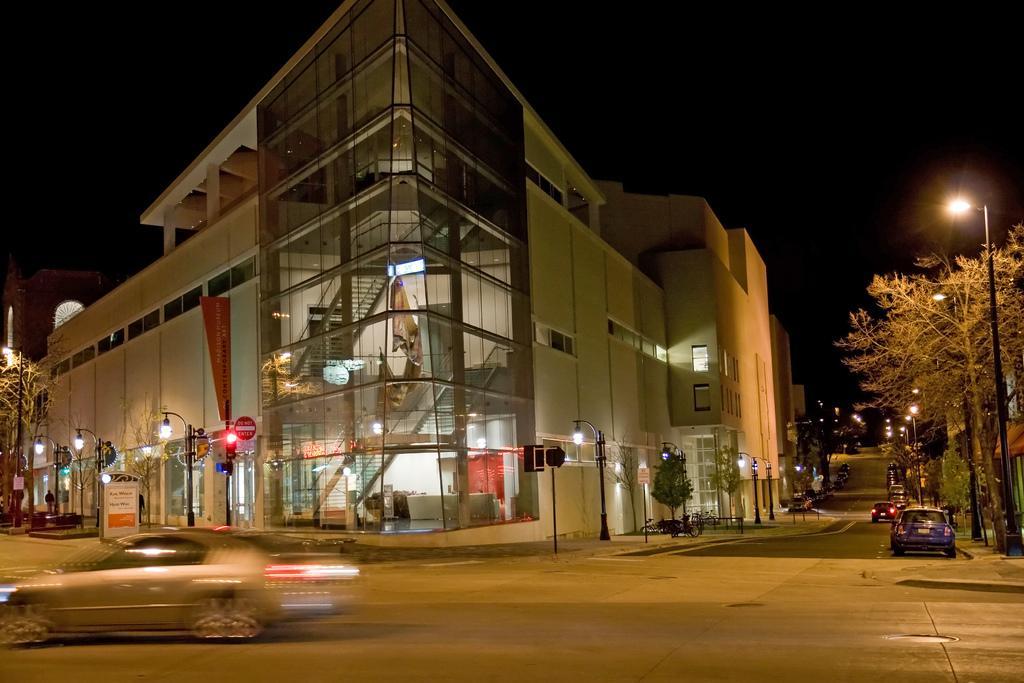Can you describe this image briefly? In this image in the center there are some buildings, poles, lights, trees and also there are some vehicles. At the bottom there is road and at the top there is sky. 